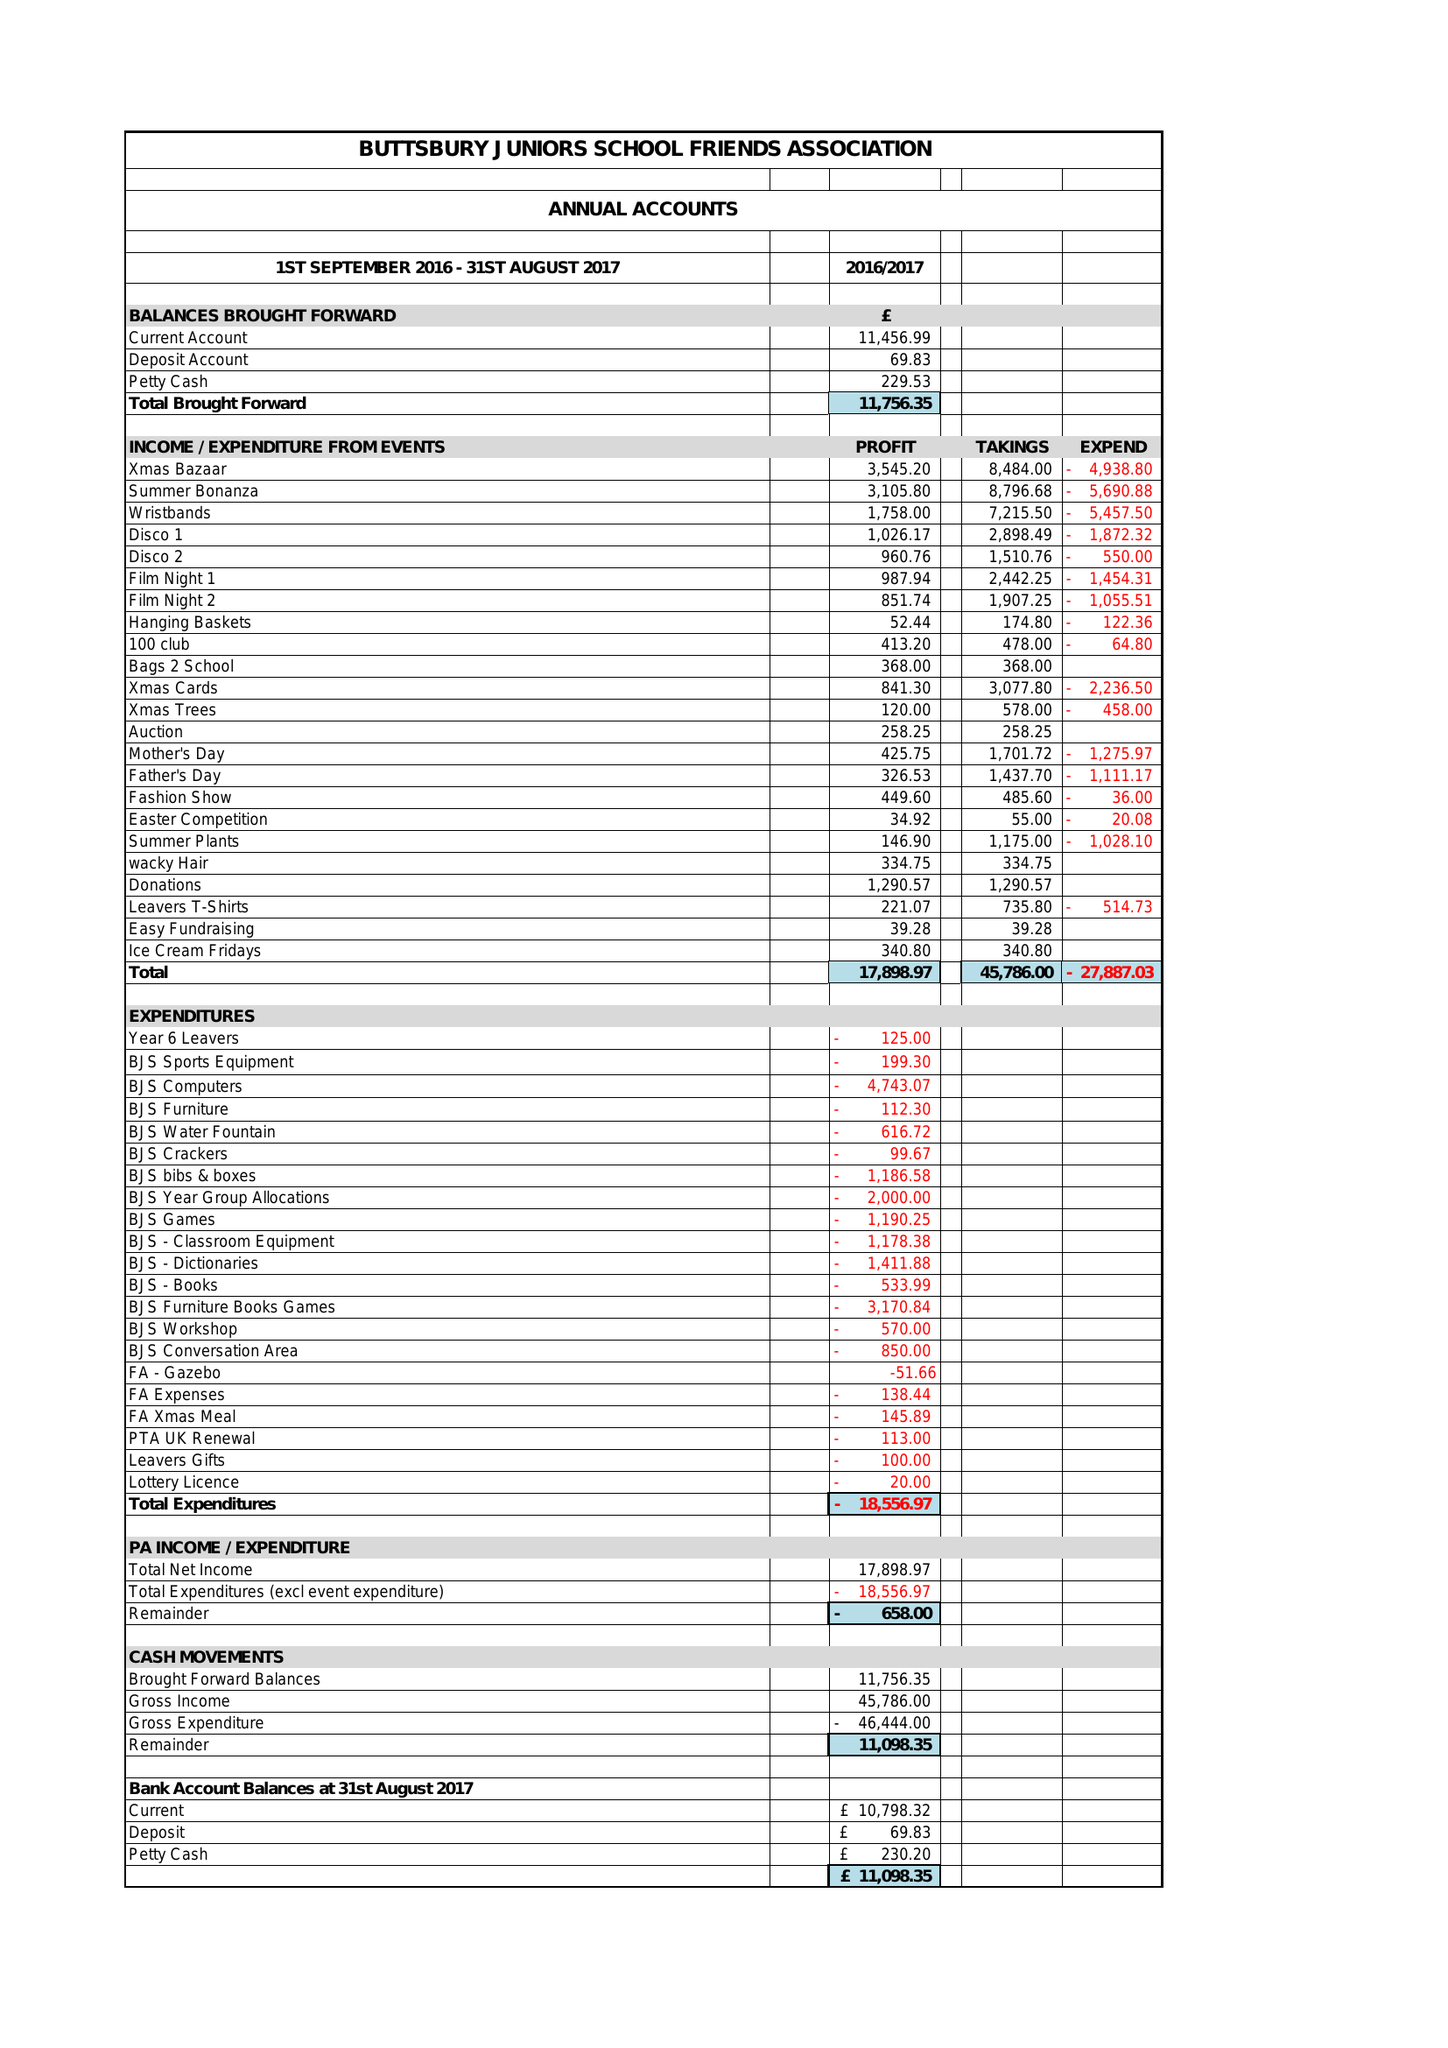What is the value for the spending_annually_in_british_pounds?
Answer the question using a single word or phrase. 46444.00 